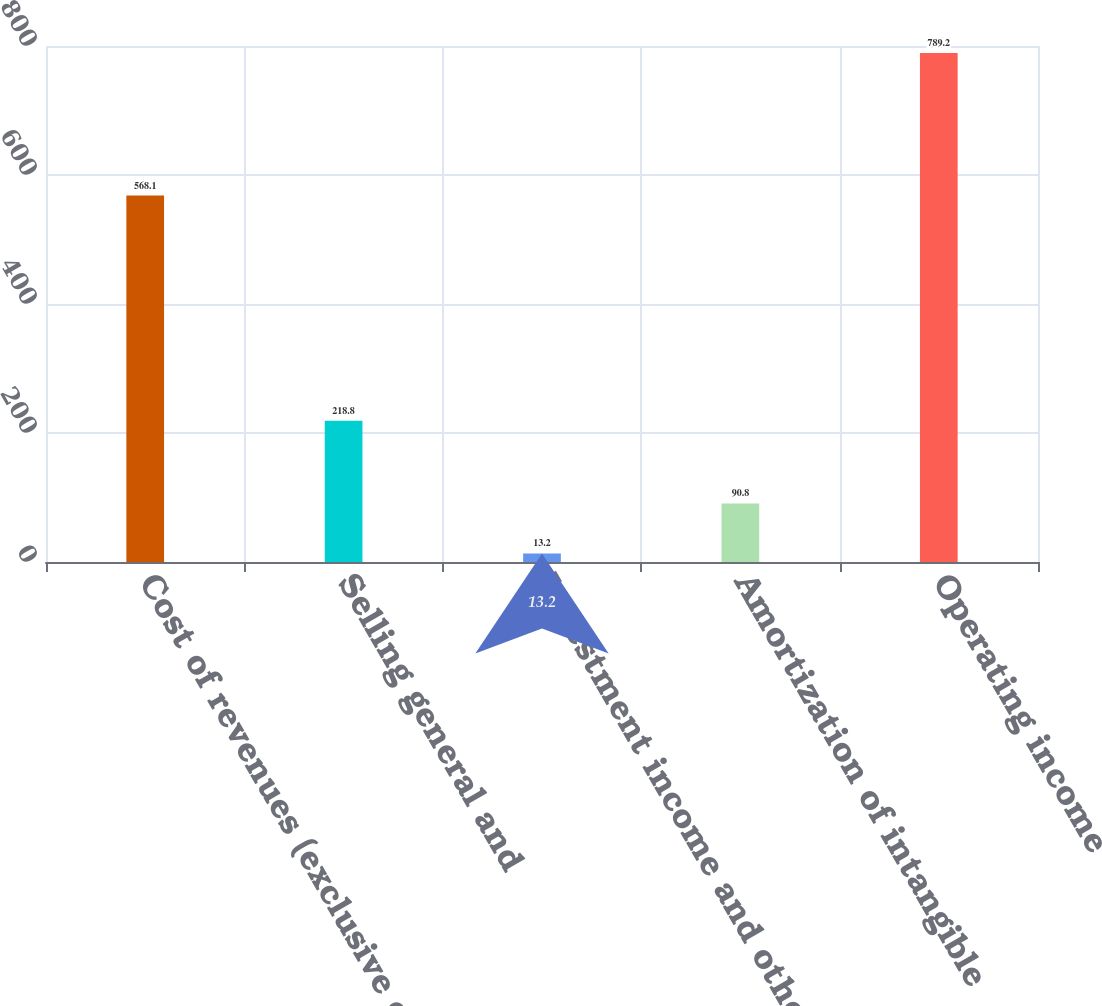Convert chart to OTSL. <chart><loc_0><loc_0><loc_500><loc_500><bar_chart><fcel>Cost of revenues (exclusive of<fcel>Selling general and<fcel>Investment income and others<fcel>Amortization of intangible<fcel>Operating income<nl><fcel>568.1<fcel>218.8<fcel>13.2<fcel>90.8<fcel>789.2<nl></chart> 